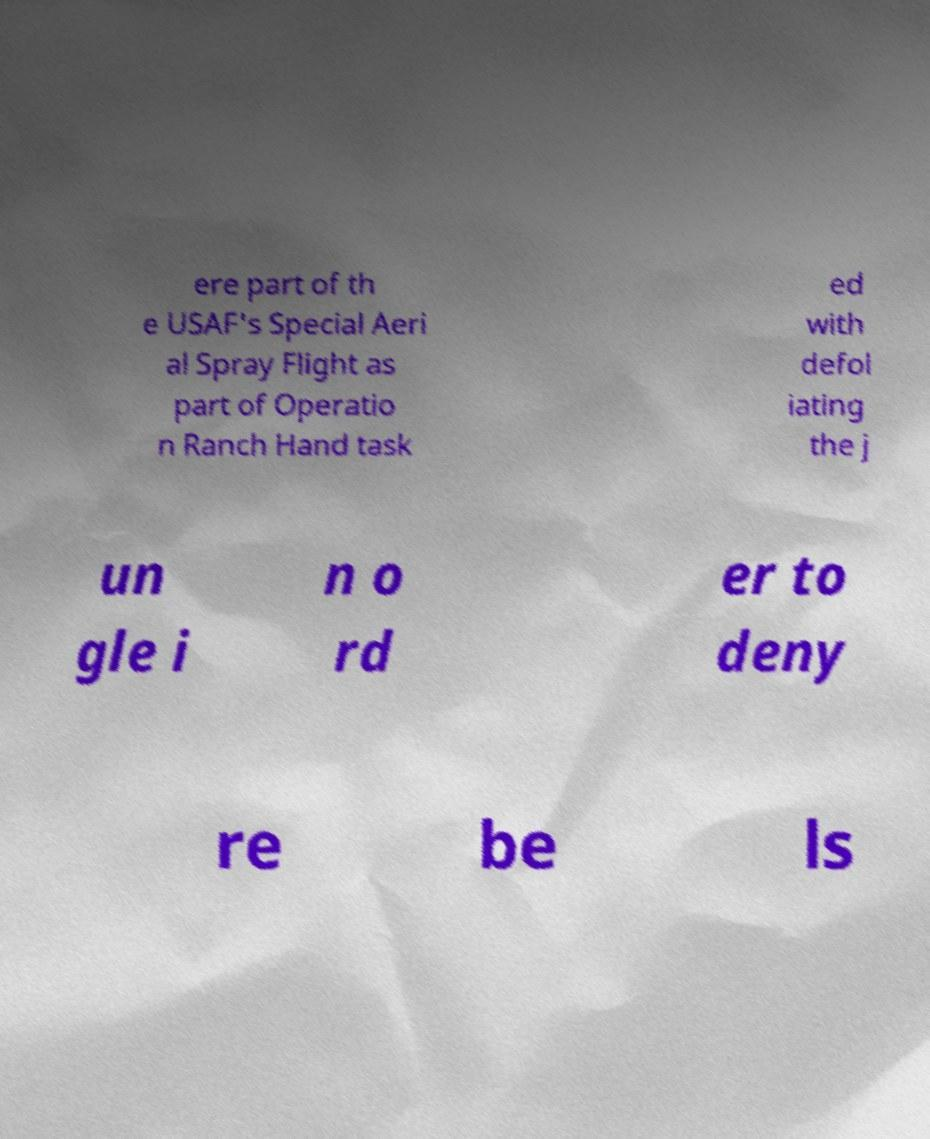Can you accurately transcribe the text from the provided image for me? ere part of th e USAF's Special Aeri al Spray Flight as part of Operatio n Ranch Hand task ed with defol iating the j un gle i n o rd er to deny re be ls 